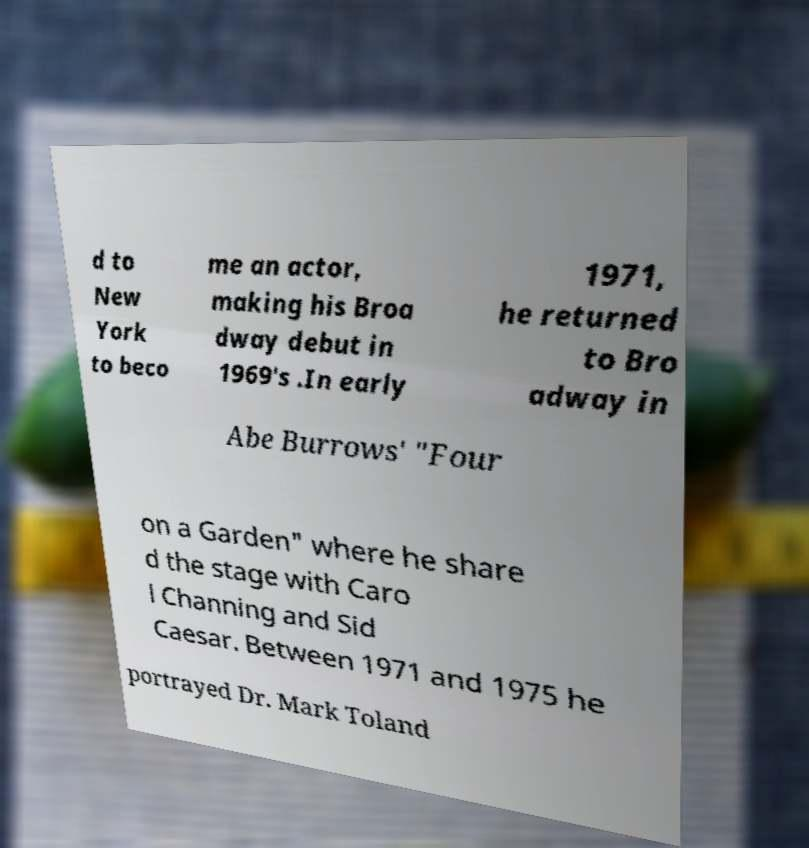There's text embedded in this image that I need extracted. Can you transcribe it verbatim? d to New York to beco me an actor, making his Broa dway debut in 1969's .In early 1971, he returned to Bro adway in Abe Burrows' "Four on a Garden" where he share d the stage with Caro l Channing and Sid Caesar. Between 1971 and 1975 he portrayed Dr. Mark Toland 